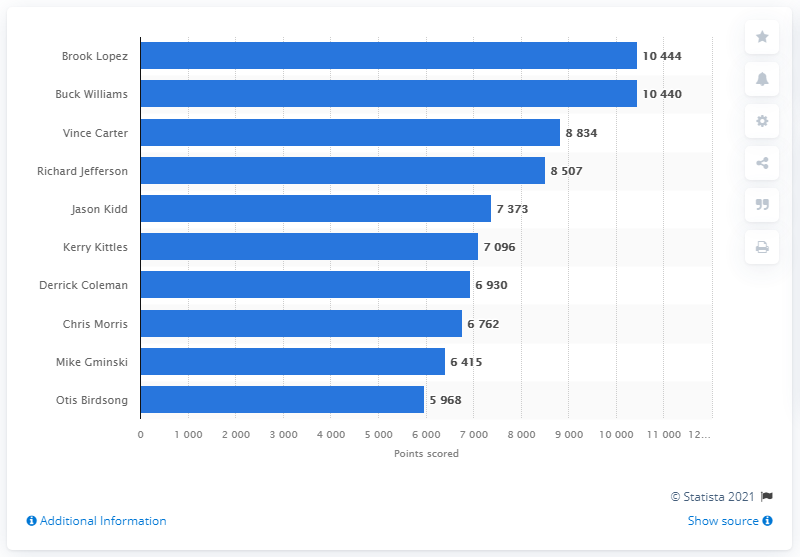Draw attention to some important aspects in this diagram. Brook Lopez is the career points leader of the Brooklyn Nets. 